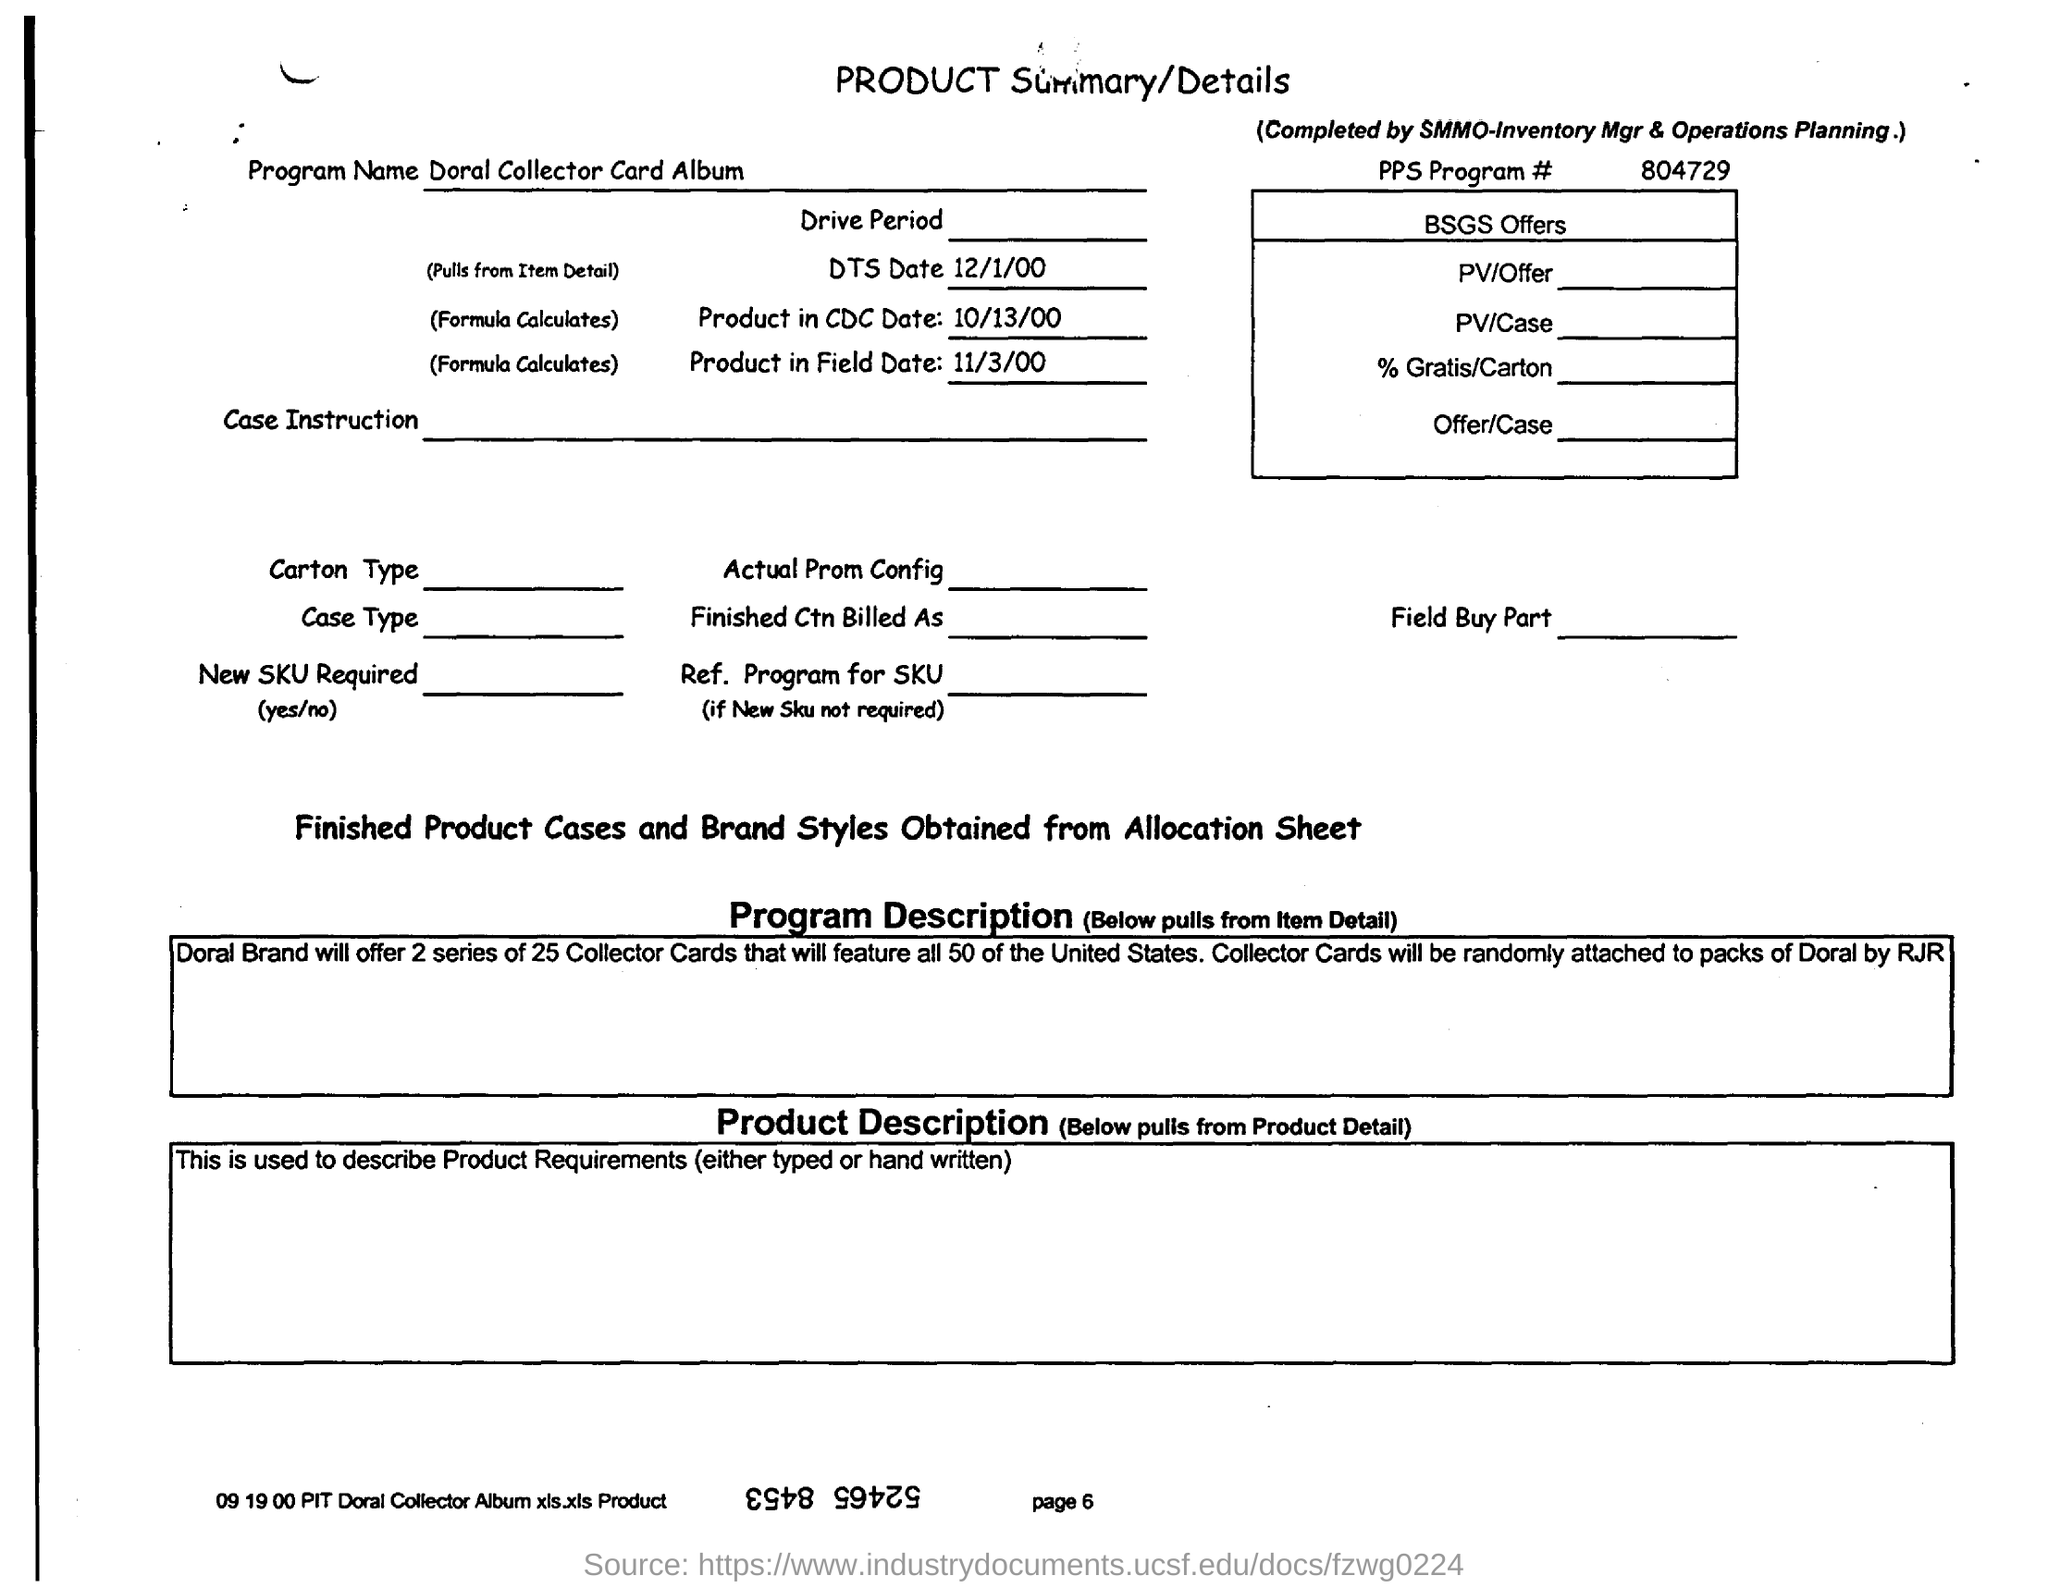What is the program name given in the product summary/details?
Offer a terse response. Doral Collector Card Album. What is the DTS Date mentioned in the product summary?
Make the answer very short. 12/1/00. What is the PPS program no given in the product summary/details?
Make the answer very short. 804729. 